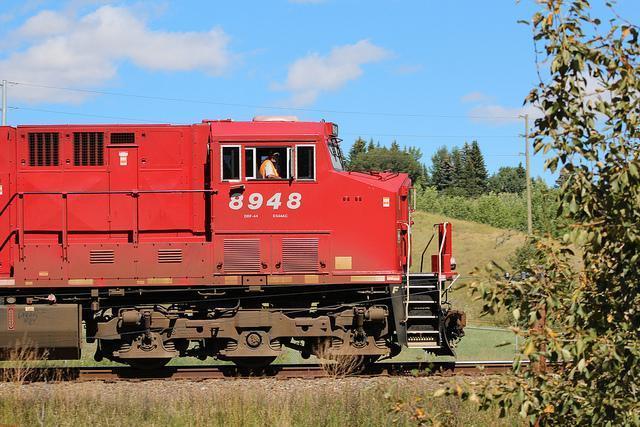How many steps do you see on the front of the train?
Give a very brief answer. 5. How many people are in the window of the train?
Give a very brief answer. 1. 